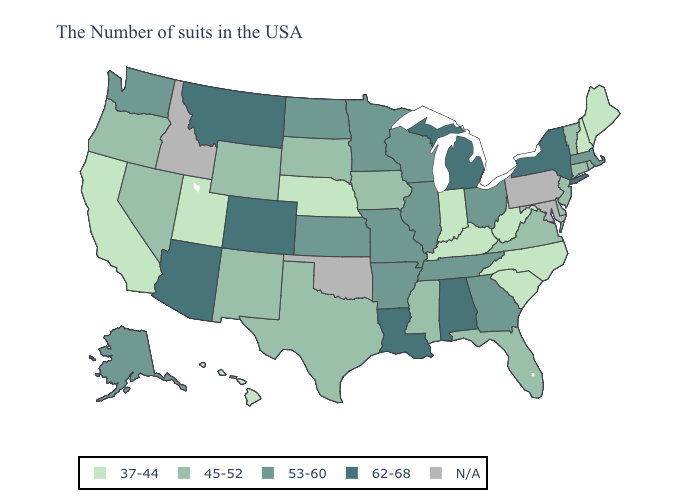Which states have the lowest value in the Northeast?
Answer briefly. Maine, New Hampshire. What is the value of Nevada?
Answer briefly. 45-52. What is the highest value in states that border Texas?
Give a very brief answer. 62-68. What is the value of Wyoming?
Answer briefly. 45-52. Name the states that have a value in the range 45-52?
Quick response, please. Rhode Island, Vermont, Connecticut, New Jersey, Delaware, Virginia, Florida, Mississippi, Iowa, Texas, South Dakota, Wyoming, New Mexico, Nevada, Oregon. Name the states that have a value in the range 62-68?
Give a very brief answer. New York, Michigan, Alabama, Louisiana, Colorado, Montana, Arizona. Which states hav the highest value in the South?
Give a very brief answer. Alabama, Louisiana. What is the lowest value in the USA?
Keep it brief. 37-44. Among the states that border Michigan , does Indiana have the lowest value?
Write a very short answer. Yes. Name the states that have a value in the range N/A?
Quick response, please. Maryland, Pennsylvania, Oklahoma, Idaho. What is the lowest value in the USA?
Concise answer only. 37-44. Name the states that have a value in the range 45-52?
Answer briefly. Rhode Island, Vermont, Connecticut, New Jersey, Delaware, Virginia, Florida, Mississippi, Iowa, Texas, South Dakota, Wyoming, New Mexico, Nevada, Oregon. Among the states that border Mississippi , which have the highest value?
Write a very short answer. Alabama, Louisiana. Among the states that border Florida , which have the lowest value?
Quick response, please. Georgia. 